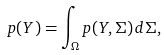<formula> <loc_0><loc_0><loc_500><loc_500>p ( Y ) = \int _ { \Omega } p ( Y , \Sigma ) \, d \Sigma ,</formula> 